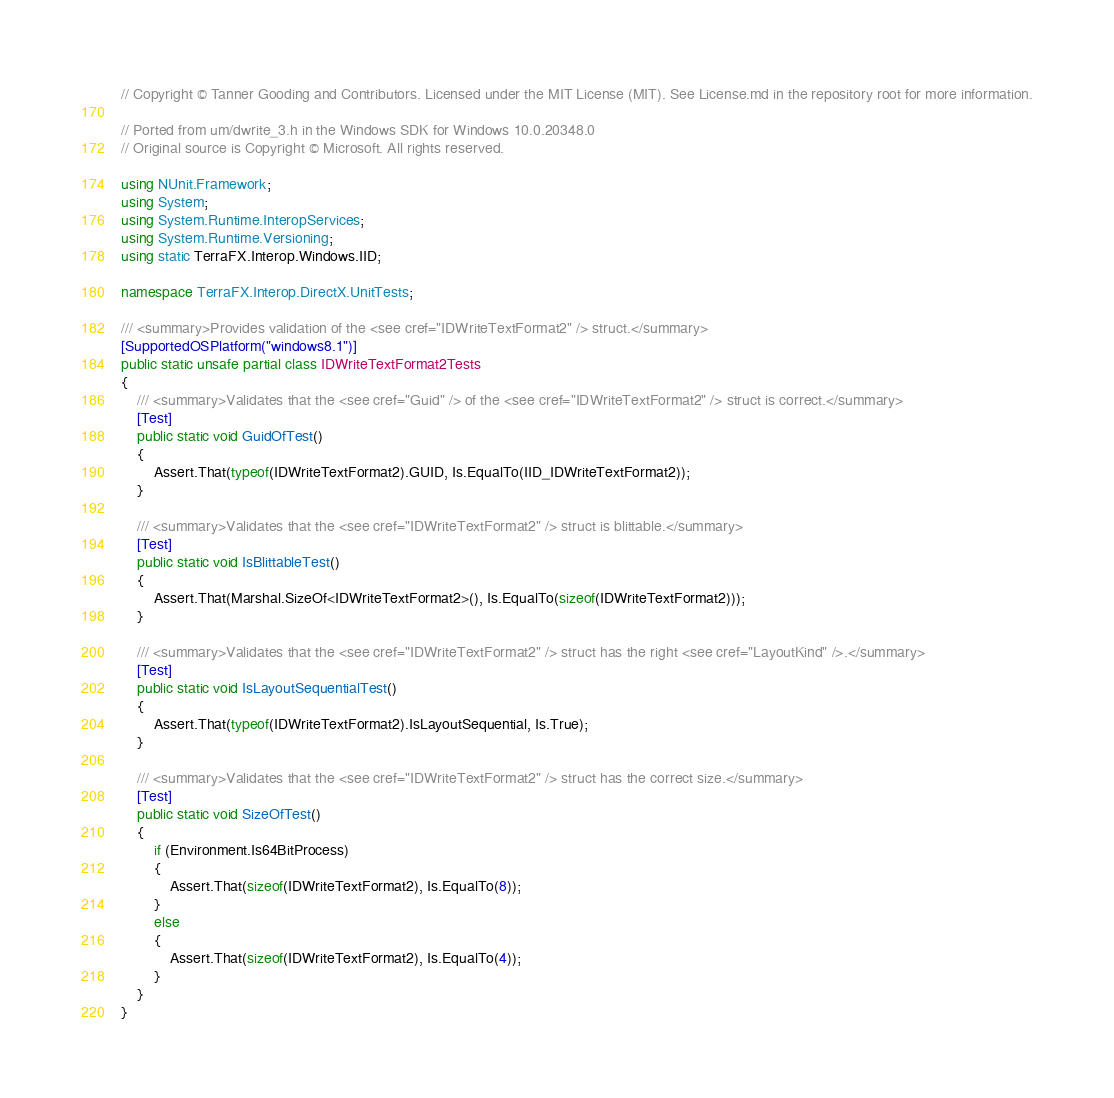<code> <loc_0><loc_0><loc_500><loc_500><_C#_>// Copyright © Tanner Gooding and Contributors. Licensed under the MIT License (MIT). See License.md in the repository root for more information.

// Ported from um/dwrite_3.h in the Windows SDK for Windows 10.0.20348.0
// Original source is Copyright © Microsoft. All rights reserved.

using NUnit.Framework;
using System;
using System.Runtime.InteropServices;
using System.Runtime.Versioning;
using static TerraFX.Interop.Windows.IID;

namespace TerraFX.Interop.DirectX.UnitTests;

/// <summary>Provides validation of the <see cref="IDWriteTextFormat2" /> struct.</summary>
[SupportedOSPlatform("windows8.1")]
public static unsafe partial class IDWriteTextFormat2Tests
{
    /// <summary>Validates that the <see cref="Guid" /> of the <see cref="IDWriteTextFormat2" /> struct is correct.</summary>
    [Test]
    public static void GuidOfTest()
    {
        Assert.That(typeof(IDWriteTextFormat2).GUID, Is.EqualTo(IID_IDWriteTextFormat2));
    }

    /// <summary>Validates that the <see cref="IDWriteTextFormat2" /> struct is blittable.</summary>
    [Test]
    public static void IsBlittableTest()
    {
        Assert.That(Marshal.SizeOf<IDWriteTextFormat2>(), Is.EqualTo(sizeof(IDWriteTextFormat2)));
    }

    /// <summary>Validates that the <see cref="IDWriteTextFormat2" /> struct has the right <see cref="LayoutKind" />.</summary>
    [Test]
    public static void IsLayoutSequentialTest()
    {
        Assert.That(typeof(IDWriteTextFormat2).IsLayoutSequential, Is.True);
    }

    /// <summary>Validates that the <see cref="IDWriteTextFormat2" /> struct has the correct size.</summary>
    [Test]
    public static void SizeOfTest()
    {
        if (Environment.Is64BitProcess)
        {
            Assert.That(sizeof(IDWriteTextFormat2), Is.EqualTo(8));
        }
        else
        {
            Assert.That(sizeof(IDWriteTextFormat2), Is.EqualTo(4));
        }
    }
}
</code> 